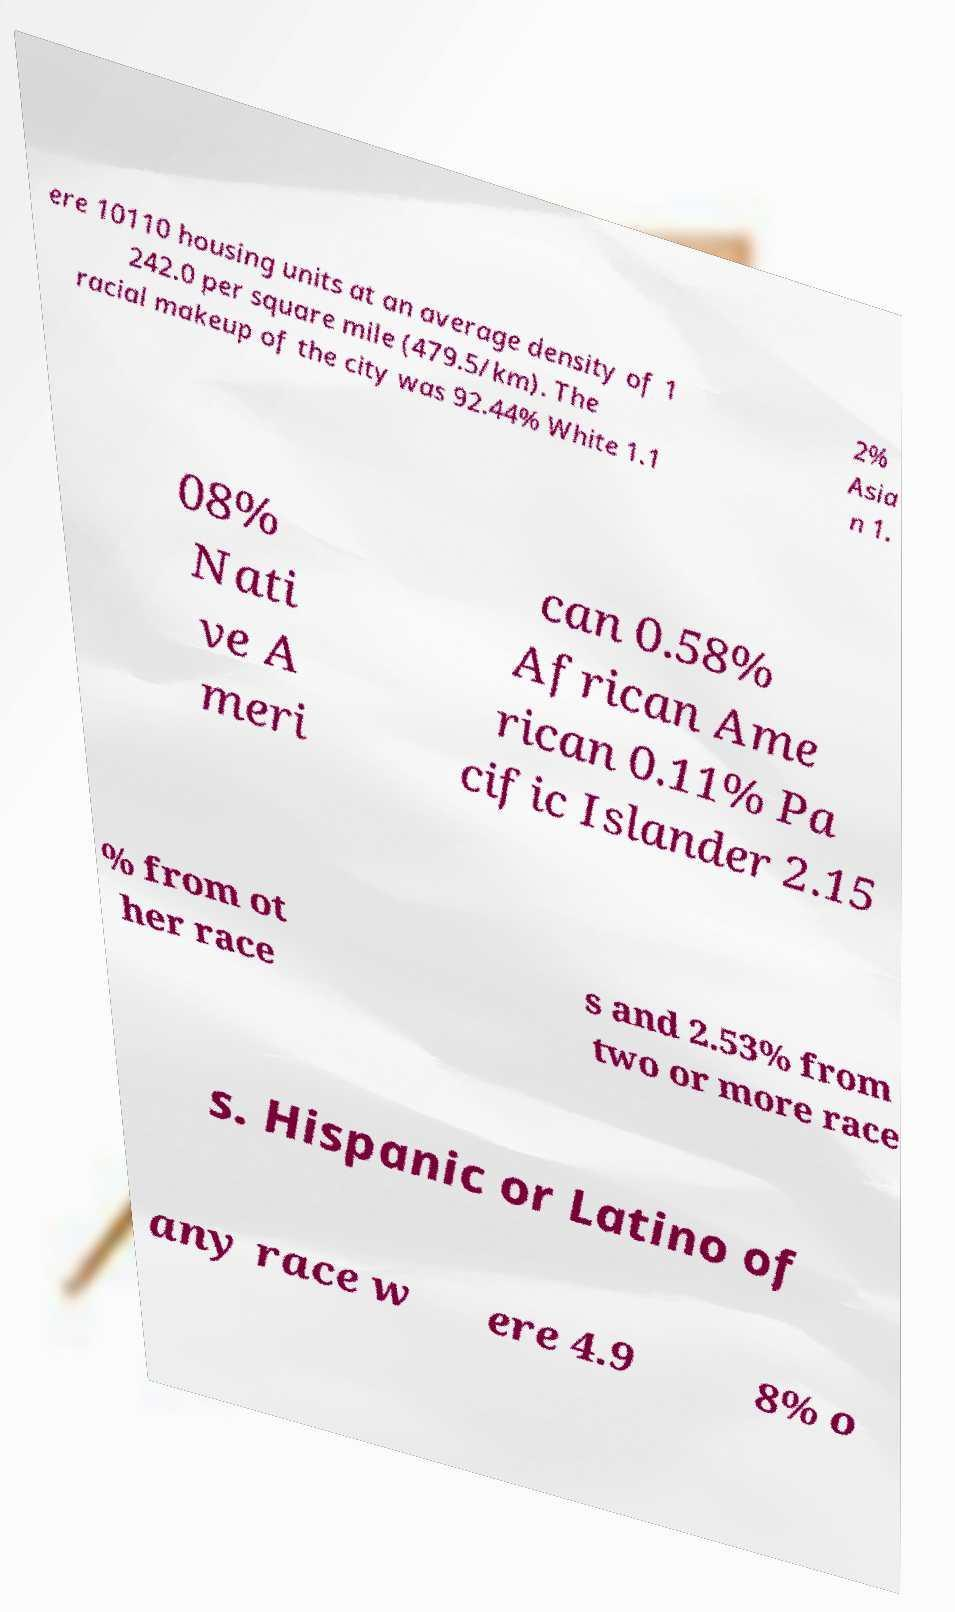Could you assist in decoding the text presented in this image and type it out clearly? ere 10110 housing units at an average density of 1 242.0 per square mile (479.5/km). The racial makeup of the city was 92.44% White 1.1 2% Asia n 1. 08% Nati ve A meri can 0.58% African Ame rican 0.11% Pa cific Islander 2.15 % from ot her race s and 2.53% from two or more race s. Hispanic or Latino of any race w ere 4.9 8% o 